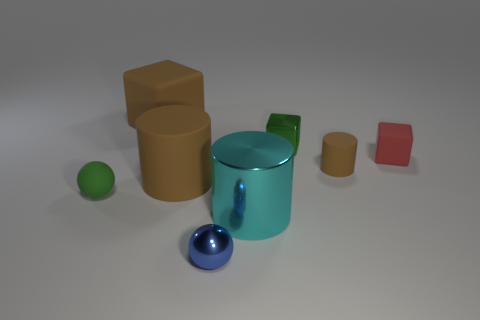Do the matte ball and the metal ball have the same color?
Give a very brief answer. No. There is a large object that is the same color as the large matte block; what is its shape?
Your response must be concise. Cylinder. What number of large things are the same shape as the tiny red rubber object?
Ensure brevity in your answer.  1. There is a cube that is the same material as the big cyan cylinder; what size is it?
Keep it short and to the point. Small. Is the size of the green block the same as the green matte sphere?
Your answer should be very brief. Yes. Are any spheres visible?
Your answer should be compact. Yes. What size is the ball that is the same color as the shiny block?
Provide a short and direct response. Small. There is a green thing that is behind the thing left of the large thing that is on the left side of the big brown matte cylinder; what is its size?
Your response must be concise. Small. How many tiny blue things are made of the same material as the cyan object?
Provide a short and direct response. 1. What number of blue balls have the same size as the red rubber cube?
Provide a succinct answer. 1. 